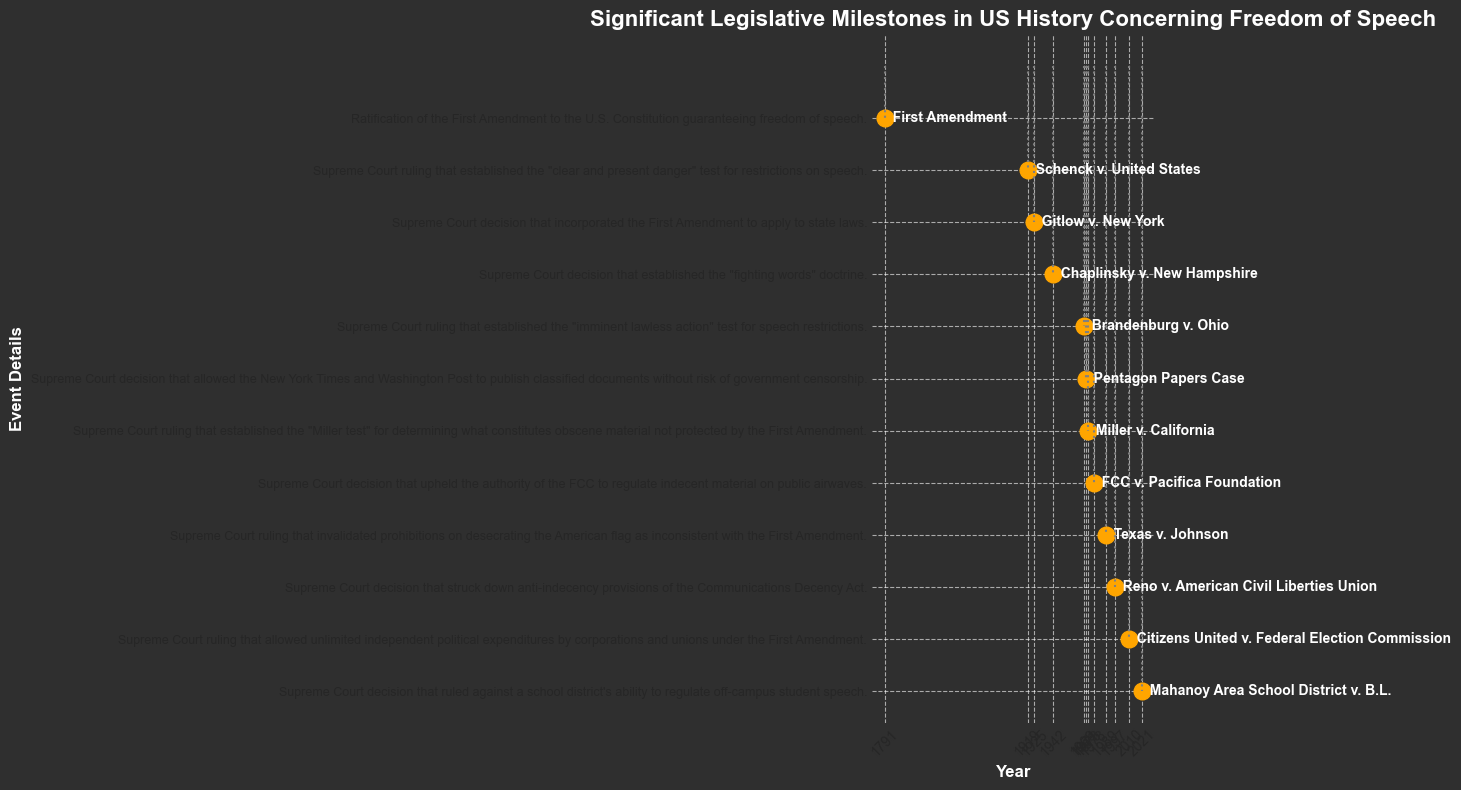What is the first legislative milestone mentioned in the plot? The first legislative milestone mentioned is represented by the year 1791. Observing the corresponding textual label beside the dot in the plot, it indicates the ratification of the First Amendment.
Answer: Ratification of the First Amendment in 1791 Which two events related to freedom of speech occurred in the 1970s according to the plot? In the 1970s, there are two events marked by the years 1971 and 1973. Referring to the textual descriptions: the Pentagon Papers Case and Miller v. California occurred in those years, respectively.
Answer: Pentagon Papers Case (1971) and Miller v. California (1973) Which event in the plot is closest to the year 2000? The event closest to the year 2000 in the plot is represented by the year 2010, with the textual label indicating Citizens United v. Federal Election Commission.
Answer: Citizens United v. Federal Election Commission (2010) What is the most recent milestone depicted in the plot and in what year did it take place? The most recent milestone depicted is marked by the year 2021. Observing the textual label beside the dot, it indicates the Mahanoy Area School District v. B.L. decision.
Answer: Mahanoy Area School District v. B.L. in 2021 Is the Pentagon Papers Case closer in time to Schenck v. United States or Reno v. American Civil Liberties Union? The Pentagon Papers Case occurred in 1971. Schenck v. United States took place in 1919, and Reno v. ACLU took place in 1997. Calculating the absolute differences: 1971-1919 = 52 years, and 1997-1971 = 26 years. The difference indicates Reno v. ACLU is closer.
Answer: Reno v. American Civil Liberties Union Comparing Schenck v. United States and Gitlow v. New York, which one occurred first? Schenck v. United States occurred in 1919, and Gitlow v. New York in 1925. Observing the years in the plot reveals that Schenck v. United States happened first.
Answer: Schenck v. United States How many legislative milestones depicted in the plot occurred before 1950? By referring to the timeline in the plot, the events that occurred before 1950 are Ratification of the First Amendment (1791), Schenck v. United States (1919), Gitlow v. New York (1925), and Chaplinsky v. New Hampshire (1942). Counting these events gives us 4.
Answer: 4 milestones What event established the "fighting words" doctrine, and in what year did it occur? To find the event associated with the "fighting words" doctrine, we locate the year 1942 in the plot and examine the corresponding label, which indicates Chaplinsky v. New Hampshire.
Answer: Chaplinsky v. New Hampshire (1942) What test was established by the 1969 Supreme Court ruling depicted in the plot, and what is the name of the associated case? The 1969 ruling established the "imminent lawless action" test. The name of the case associated with this ruling is Brandenburg v. Ohio, as shown in the plot.
Answer: "Imminent lawless action" test; Brandenburg v. Ohio 